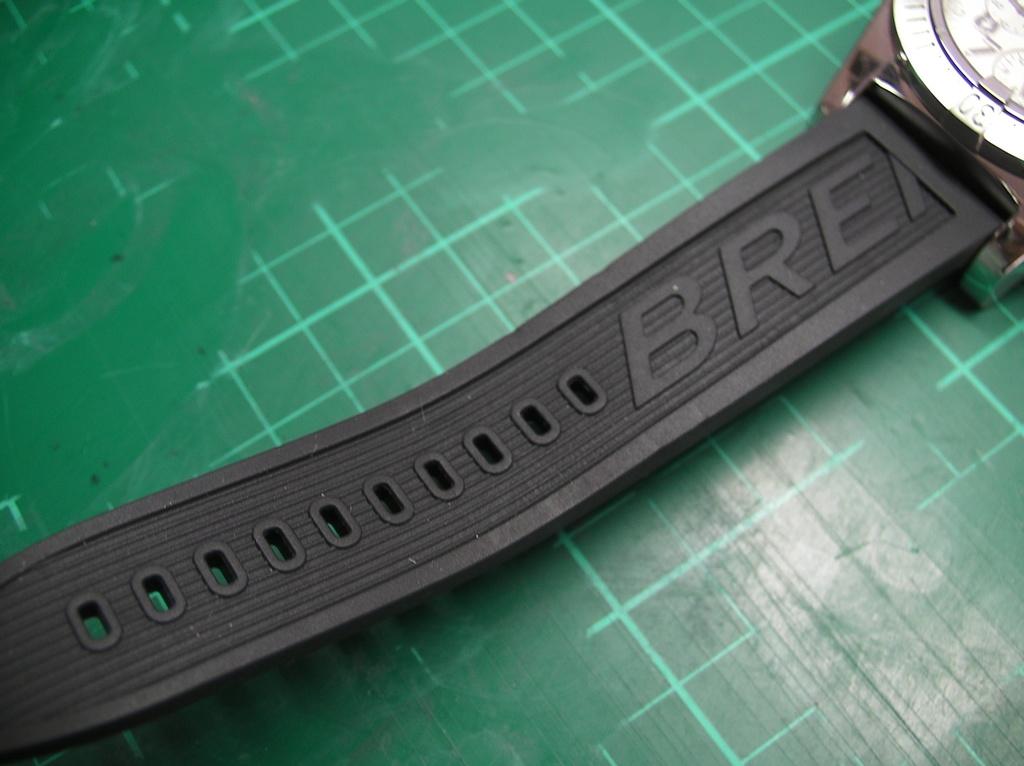What 3 letters are embossed on the watch band?
Provide a short and direct response. Bre. 